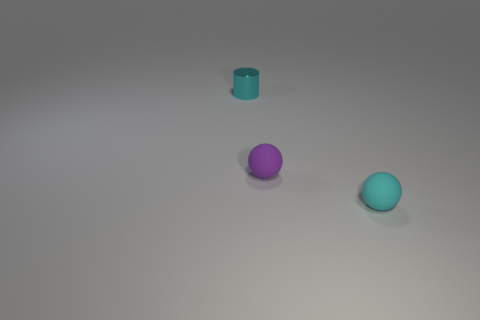How many other things are there of the same size as the cyan sphere?
Your answer should be compact. 2. What size is the object that is behind the cyan matte object and on the right side of the metallic cylinder?
Keep it short and to the point. Small. Do the cylinder and the small ball in front of the purple matte object have the same color?
Keep it short and to the point. Yes. Are there any tiny cyan rubber things of the same shape as the small purple rubber thing?
Give a very brief answer. Yes. How many things are small cyan cylinders or cyan things that are in front of the shiny thing?
Provide a short and direct response. 2. What number of other objects are there of the same material as the purple ball?
Provide a short and direct response. 1. What number of things are either purple objects or shiny cylinders?
Offer a terse response. 2. Is the number of tiny cyan matte things to the right of the tiny purple rubber thing greater than the number of tiny spheres on the left side of the small metallic cylinder?
Your answer should be very brief. Yes. There is a tiny thing that is on the left side of the tiny purple rubber thing; is it the same color as the rubber thing that is right of the tiny purple rubber object?
Offer a very short reply. Yes. There is another tiny object that is the same shape as the purple matte object; what color is it?
Keep it short and to the point. Cyan. 